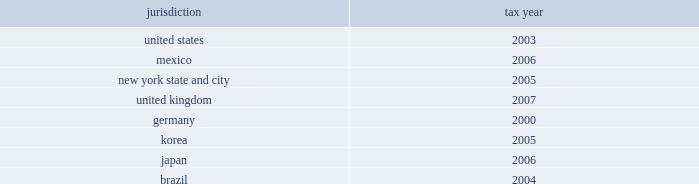The company is currently under audit by the internal revenue service and other major taxing jurisdictions around the world .
It is thus reasonably possible that significant changes in the gross balance of unrecognized tax benefits may occur within the next 12 months , but the company does not expect such audits to result in amounts that would cause a significant change to its effective tax rate , other than the following items .
The company is currently at irs appeals for the years 1999 20132002 .
One of the issues relates to the timing of the inclusion of interchange fees received by the company relating to credit card purchases by its cardholders .
It is reasonably possible that within the next 12 months the company can either reach agreement on this issue at appeals or decide to litigate the issue .
This issue is presently being litigated by another company in a united states tax court case .
The gross uncertain tax position for this item at december 31 , 2008 is $ 542 million .
Since this is a temporary difference , the only effect to the company 2019s effective tax rate would be due to net interest and state tax rate differentials .
If the reserve were to be released , the tax benefit could be as much as $ 168 million .
In addition , the company expects to conclude the irs audit of its u.s .
Federal consolidated income tax returns for the years 2003 20132005 within the next 12 months .
The gross uncertain tax position at december 31 , 2008 for the items expected to be resolved is approximately $ 350 million plus gross interest of $ 70 million .
The potential net tax benefit to continuing operations could be approximately $ 325 million .
The following are the major tax jurisdictions in which the company and its affiliates operate and the earliest tax year subject to examination: .
Foreign pretax earnings approximated $ 10.3 billion in 2008 , $ 9.1 billion in 2007 , and $ 13.6 billion in 2006 ( $ 5.1 billion , $ 0.7 billion and $ 0.9 billion of which , respectively , are in discontinued operations ) .
As a u.s .
Corporation , citigroup and its u.s .
Subsidiaries are subject to u.s .
Taxation currently on all foreign pretax earnings earned by a foreign branch .
Pretax earnings of a foreign subsidiary or affiliate are subject to u.s .
Taxation when effectively repatriated .
The company provides income taxes on the undistributed earnings of non-u.s .
Subsidiaries except to the extent that such earnings are indefinitely invested outside the united states .
At december 31 , 2008 , $ 22.8 billion of accumulated undistributed earnings of non-u.s .
Subsidiaries were indefinitely invested .
At the existing u.s .
Federal income tax rate , additional taxes ( net of u.s .
Foreign tax credits ) of $ 6.1 billion would have to be provided if such earnings were remitted currently .
The current year 2019s effect on the income tax expense from continuing operations is included in the foreign income tax rate differential line in the reconciliation of the federal statutory rate to the company 2019s effective income tax rate on the previous page .
Income taxes are not provided for on the company 2019s savings bank base year bad debt reserves that arose before 1988 because under current u.s .
Tax rules such taxes will become payable only to the extent such amounts are distributed in excess of limits prescribed by federal law .
At december 31 , 2008 , the amount of the base year reserves totaled approximately $ 358 million ( subject to a tax of $ 125 million ) .
The company has no valuation allowance on deferred tax assets at december 31 , 2008 and december 31 , 2007 .
At december 31 , 2008 , the company had a u.s .
Foreign tax-credit carryforward of $ 10.5 billion , $ 0.4 billion whose expiry date is 2016 , $ 5.3 billion whose expiry date is 2017 and $ 4.8 billion whose expiry date is 2018 .
The company has a u.s federal consolidated net operating loss ( nol ) carryforward of approximately $ 13 billion whose expiration date is 2028 .
The company also has a general business credit carryforward of $ 0.6 billion whose expiration dates are 2027-2028 .
The company has state and local net operating loss carryforwards of $ 16.2 billion and $ 4.9 billion in new york state and new york city , respectively .
This consists of $ 2.4 billion and $ 1.2 billion , whose expiration date is 2027 and $ 13.8 billion and $ 3.7 billion whose expiration date is 2028 and for which the company has recorded a deferred-tax asset of $ 1.2 billion , along with less significant net operating losses in various other states for which the company has recorded a deferred-tax asset of $ 399 million and which expire between 2012 and 2028 .
In addition , the company has recorded deferred-tax assets in apb 23 subsidiaries for foreign net operating loss carryforwards of $ 130 million ( which expires in 2018 ) and $ 101 million ( with no expiration ) .
Although realization is not assured , the company believes that the realization of the recognized net deferred tax asset of $ 44.5 billion is more likely than not based on expectations as to future taxable income in the jurisdictions in which it operates and available tax planning strategies , as defined in sfas 109 , that could be implemented if necessary to prevent a carryforward from expiring .
The company 2019s net deferred tax asset ( dta ) of $ 44.5 billion consists of approximately $ 36.5 billion of net u.s .
Federal dtas , $ 4 billion of net state dtas and $ 4 billion of net foreign dtas .
Included in the net federal dta of $ 36.5 billion are deferred tax liabilities of $ 4 billion that will reverse in the relevant carryforward period and may be used to support the dta .
The major components of the u.s .
Federal dta are $ 10.5 billion in foreign tax-credit carryforwards , $ 4.6 billion in a net-operating-loss carryforward , $ 0.6 billion in a general-business-credit carryforward , $ 19.9 billion in net deductions that have not yet been taken on a tax return , and $ 0.9 billion in compensation deductions , which reduced additional paid-in capital in january 2009 and for which sfas 123 ( r ) did not permit any adjustment to such dta at december 31 , 2008 because the related stock compensation was not yet deductible to the company .
In general , citigroup would need to generate approximately $ 85 billion of taxable income during the respective carryforward periods to fully realize its federal , state and local dtas. .
What was the percentage of the company 2019s net deferred tax asset attributable to the net u.s . federal dtas? 
Computations: (36.5 / 44.5)
Answer: 0.82022. The company is currently under audit by the internal revenue service and other major taxing jurisdictions around the world .
It is thus reasonably possible that significant changes in the gross balance of unrecognized tax benefits may occur within the next 12 months , but the company does not expect such audits to result in amounts that would cause a significant change to its effective tax rate , other than the following items .
The company is currently at irs appeals for the years 1999 20132002 .
One of the issues relates to the timing of the inclusion of interchange fees received by the company relating to credit card purchases by its cardholders .
It is reasonably possible that within the next 12 months the company can either reach agreement on this issue at appeals or decide to litigate the issue .
This issue is presently being litigated by another company in a united states tax court case .
The gross uncertain tax position for this item at december 31 , 2008 is $ 542 million .
Since this is a temporary difference , the only effect to the company 2019s effective tax rate would be due to net interest and state tax rate differentials .
If the reserve were to be released , the tax benefit could be as much as $ 168 million .
In addition , the company expects to conclude the irs audit of its u.s .
Federal consolidated income tax returns for the years 2003 20132005 within the next 12 months .
The gross uncertain tax position at december 31 , 2008 for the items expected to be resolved is approximately $ 350 million plus gross interest of $ 70 million .
The potential net tax benefit to continuing operations could be approximately $ 325 million .
The following are the major tax jurisdictions in which the company and its affiliates operate and the earliest tax year subject to examination: .
Foreign pretax earnings approximated $ 10.3 billion in 2008 , $ 9.1 billion in 2007 , and $ 13.6 billion in 2006 ( $ 5.1 billion , $ 0.7 billion and $ 0.9 billion of which , respectively , are in discontinued operations ) .
As a u.s .
Corporation , citigroup and its u.s .
Subsidiaries are subject to u.s .
Taxation currently on all foreign pretax earnings earned by a foreign branch .
Pretax earnings of a foreign subsidiary or affiliate are subject to u.s .
Taxation when effectively repatriated .
The company provides income taxes on the undistributed earnings of non-u.s .
Subsidiaries except to the extent that such earnings are indefinitely invested outside the united states .
At december 31 , 2008 , $ 22.8 billion of accumulated undistributed earnings of non-u.s .
Subsidiaries were indefinitely invested .
At the existing u.s .
Federal income tax rate , additional taxes ( net of u.s .
Foreign tax credits ) of $ 6.1 billion would have to be provided if such earnings were remitted currently .
The current year 2019s effect on the income tax expense from continuing operations is included in the foreign income tax rate differential line in the reconciliation of the federal statutory rate to the company 2019s effective income tax rate on the previous page .
Income taxes are not provided for on the company 2019s savings bank base year bad debt reserves that arose before 1988 because under current u.s .
Tax rules such taxes will become payable only to the extent such amounts are distributed in excess of limits prescribed by federal law .
At december 31 , 2008 , the amount of the base year reserves totaled approximately $ 358 million ( subject to a tax of $ 125 million ) .
The company has no valuation allowance on deferred tax assets at december 31 , 2008 and december 31 , 2007 .
At december 31 , 2008 , the company had a u.s .
Foreign tax-credit carryforward of $ 10.5 billion , $ 0.4 billion whose expiry date is 2016 , $ 5.3 billion whose expiry date is 2017 and $ 4.8 billion whose expiry date is 2018 .
The company has a u.s federal consolidated net operating loss ( nol ) carryforward of approximately $ 13 billion whose expiration date is 2028 .
The company also has a general business credit carryforward of $ 0.6 billion whose expiration dates are 2027-2028 .
The company has state and local net operating loss carryforwards of $ 16.2 billion and $ 4.9 billion in new york state and new york city , respectively .
This consists of $ 2.4 billion and $ 1.2 billion , whose expiration date is 2027 and $ 13.8 billion and $ 3.7 billion whose expiration date is 2028 and for which the company has recorded a deferred-tax asset of $ 1.2 billion , along with less significant net operating losses in various other states for which the company has recorded a deferred-tax asset of $ 399 million and which expire between 2012 and 2028 .
In addition , the company has recorded deferred-tax assets in apb 23 subsidiaries for foreign net operating loss carryforwards of $ 130 million ( which expires in 2018 ) and $ 101 million ( with no expiration ) .
Although realization is not assured , the company believes that the realization of the recognized net deferred tax asset of $ 44.5 billion is more likely than not based on expectations as to future taxable income in the jurisdictions in which it operates and available tax planning strategies , as defined in sfas 109 , that could be implemented if necessary to prevent a carryforward from expiring .
The company 2019s net deferred tax asset ( dta ) of $ 44.5 billion consists of approximately $ 36.5 billion of net u.s .
Federal dtas , $ 4 billion of net state dtas and $ 4 billion of net foreign dtas .
Included in the net federal dta of $ 36.5 billion are deferred tax liabilities of $ 4 billion that will reverse in the relevant carryforward period and may be used to support the dta .
The major components of the u.s .
Federal dta are $ 10.5 billion in foreign tax-credit carryforwards , $ 4.6 billion in a net-operating-loss carryforward , $ 0.6 billion in a general-business-credit carryforward , $ 19.9 billion in net deductions that have not yet been taken on a tax return , and $ 0.9 billion in compensation deductions , which reduced additional paid-in capital in january 2009 and for which sfas 123 ( r ) did not permit any adjustment to such dta at december 31 , 2008 because the related stock compensation was not yet deductible to the company .
In general , citigroup would need to generate approximately $ 85 billion of taxable income during the respective carryforward periods to fully realize its federal , state and local dtas. .
At december 31 , 2008 what was the percent of the gross interest associated to the gross uncertain tax position expected to be resolved to? 
Computations: (70 / 350)
Answer: 0.2. 